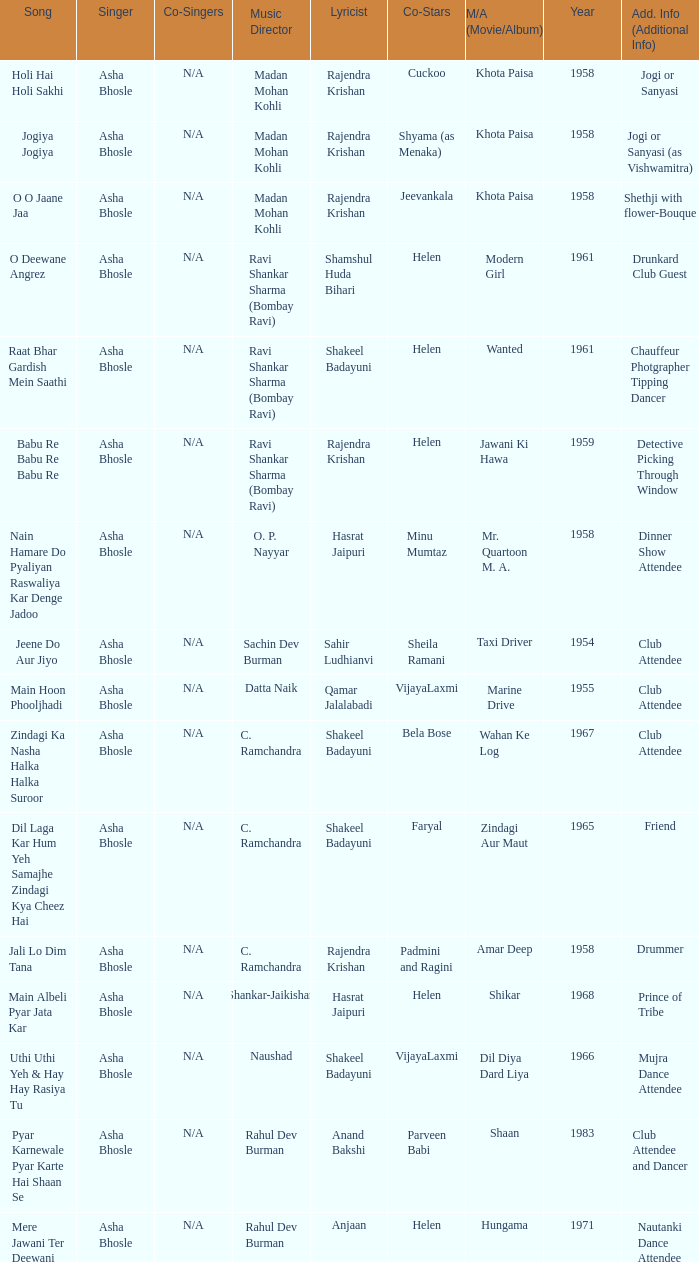Who sang for the movie Amar Deep? Asha Bhosle. 